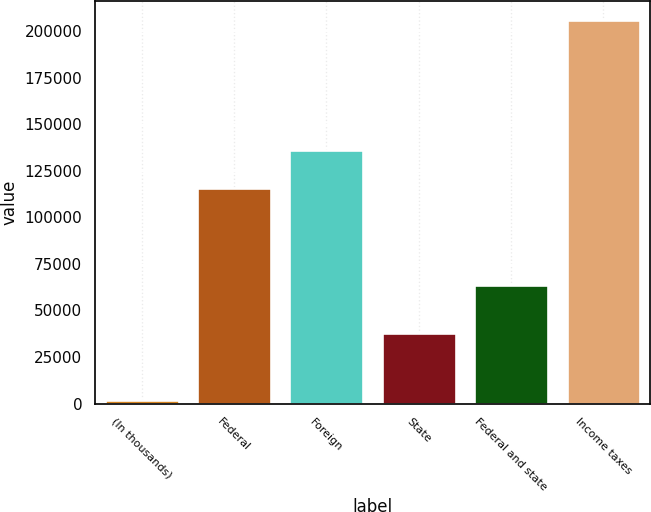Convert chart. <chart><loc_0><loc_0><loc_500><loc_500><bar_chart><fcel>(In thousands)<fcel>Federal<fcel>Foreign<fcel>State<fcel>Federal and state<fcel>Income taxes<nl><fcel>2016<fcel>115570<fcel>135955<fcel>37957<fcel>63610<fcel>205862<nl></chart> 